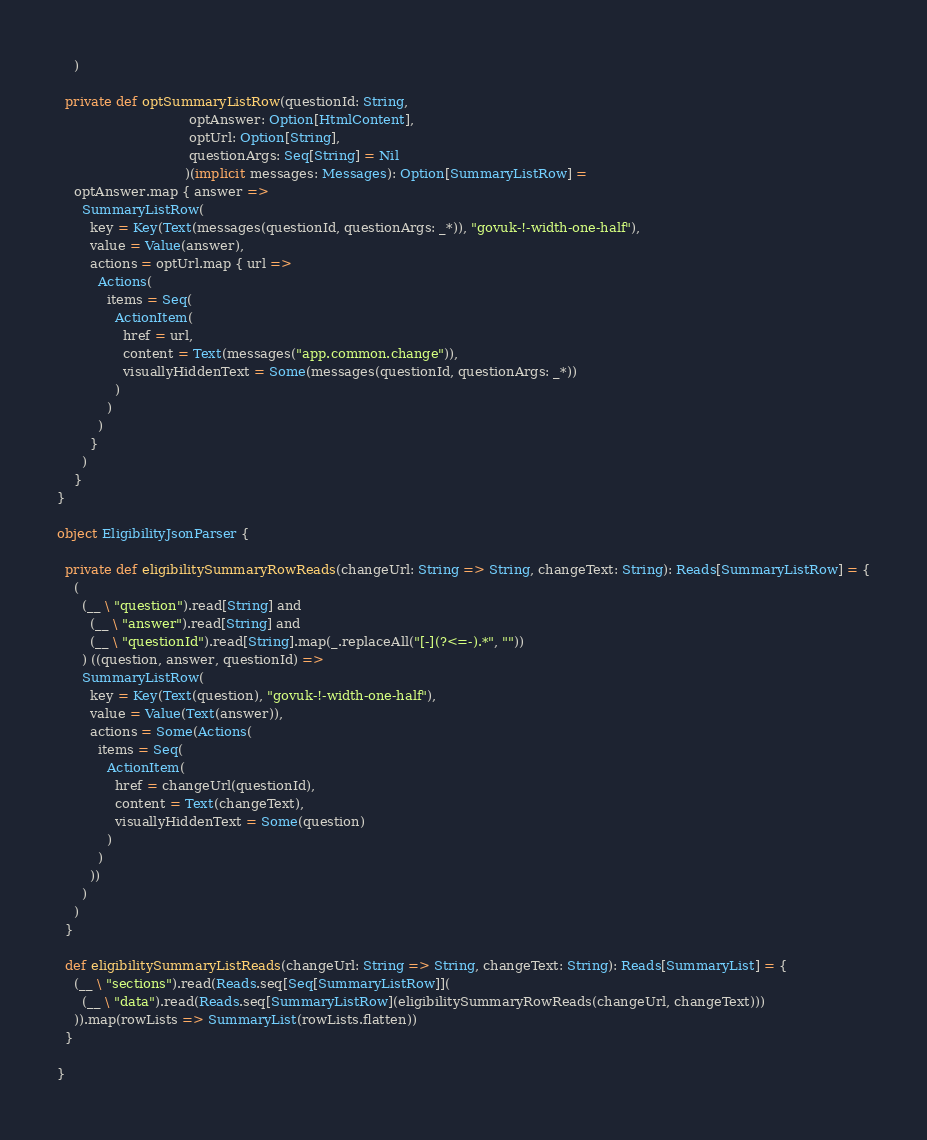Convert code to text. <code><loc_0><loc_0><loc_500><loc_500><_Scala_>    )

  private def optSummaryListRow(questionId: String,
                                optAnswer: Option[HtmlContent],
                                optUrl: Option[String],
                                questionArgs: Seq[String] = Nil
                               )(implicit messages: Messages): Option[SummaryListRow] =
    optAnswer.map { answer =>
      SummaryListRow(
        key = Key(Text(messages(questionId, questionArgs: _*)), "govuk-!-width-one-half"),
        value = Value(answer),
        actions = optUrl.map { url =>
          Actions(
            items = Seq(
              ActionItem(
                href = url,
                content = Text(messages("app.common.change")),
                visuallyHiddenText = Some(messages(questionId, questionArgs: _*))
              )
            )
          )
        }
      )
    }
}

object EligibilityJsonParser {

  private def eligibilitySummaryRowReads(changeUrl: String => String, changeText: String): Reads[SummaryListRow] = {
    (
      (__ \ "question").read[String] and
        (__ \ "answer").read[String] and
        (__ \ "questionId").read[String].map(_.replaceAll("[-](?<=-).*", ""))
      ) ((question, answer, questionId) =>
      SummaryListRow(
        key = Key(Text(question), "govuk-!-width-one-half"),
        value = Value(Text(answer)),
        actions = Some(Actions(
          items = Seq(
            ActionItem(
              href = changeUrl(questionId),
              content = Text(changeText),
              visuallyHiddenText = Some(question)
            )
          )
        ))
      )
    )
  }

  def eligibilitySummaryListReads(changeUrl: String => String, changeText: String): Reads[SummaryList] = {
    (__ \ "sections").read(Reads.seq[Seq[SummaryListRow]](
      (__ \ "data").read(Reads.seq[SummaryListRow](eligibilitySummaryRowReads(changeUrl, changeText)))
    )).map(rowLists => SummaryList(rowLists.flatten))
  }

}</code> 